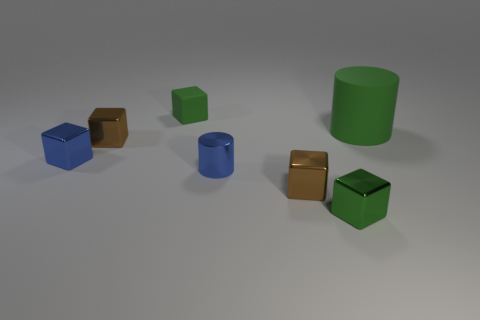What number of rubber things are green cylinders or brown cylinders?
Your answer should be very brief. 1. What is the size of the brown metal cube right of the rubber block?
Give a very brief answer. Small. Does the tiny matte object have the same shape as the green metallic object?
Your answer should be compact. Yes. What number of big objects are either brown cubes or green metal things?
Your answer should be very brief. 0. Are there any tiny brown metal things right of the green metallic cube?
Your answer should be compact. No. Are there the same number of green rubber objects to the right of the large object and blue rubber cylinders?
Keep it short and to the point. Yes. Do the large object and the tiny blue thing right of the blue cube have the same shape?
Your answer should be compact. Yes. There is a rubber thing in front of the green thing left of the blue metallic cylinder; what size is it?
Your answer should be compact. Large. Are there an equal number of small cylinders on the left side of the blue cylinder and green blocks that are in front of the tiny blue cube?
Give a very brief answer. No. There is a metallic object that is the same shape as the large rubber thing; what is its color?
Your answer should be compact. Blue. 